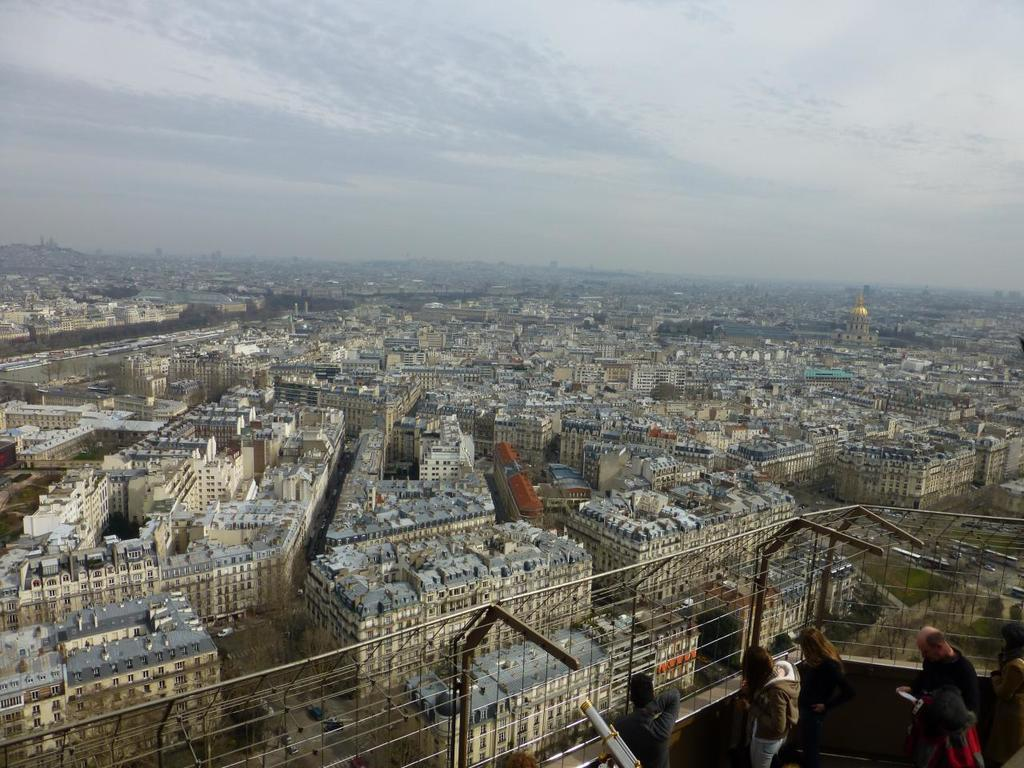What is located at the front of the image? There are people standing in the front of the image. What can be seen in the background of the image? There are buildings and clouds visible in the background of the image. What is the color of the sky in the image? The sky is visible in the background of the image, but the color is not mentioned in the facts. What type of scissors are being used by the people in the image? There is no mention of scissors in the image, so we cannot determine if they are being used or not. 